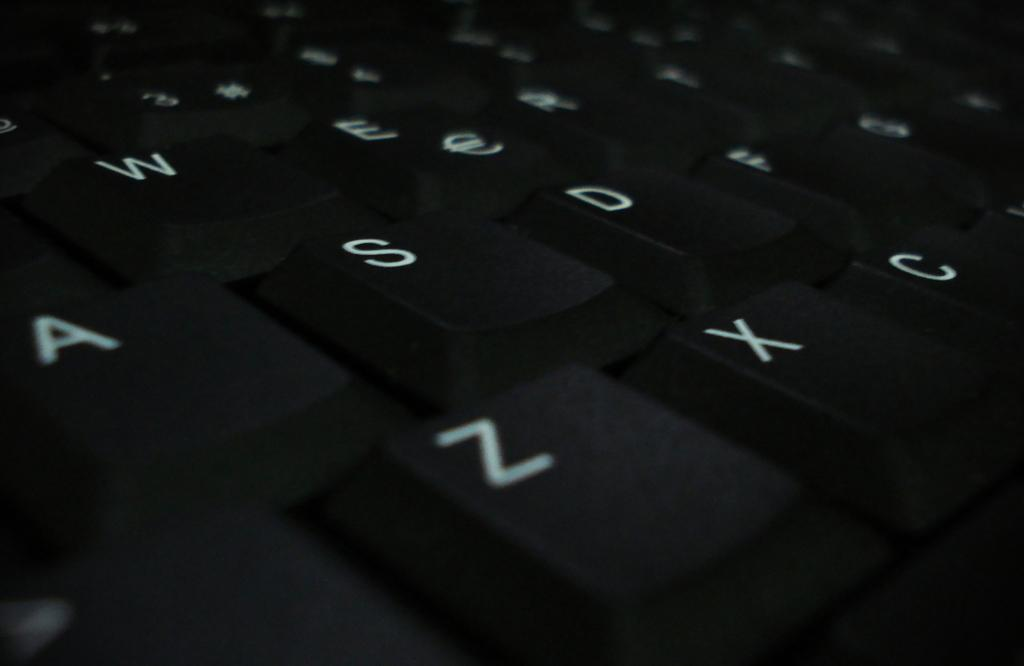<image>
Write a terse but informative summary of the picture. A close up on a keyboard with the letter Z in the bottom left. 